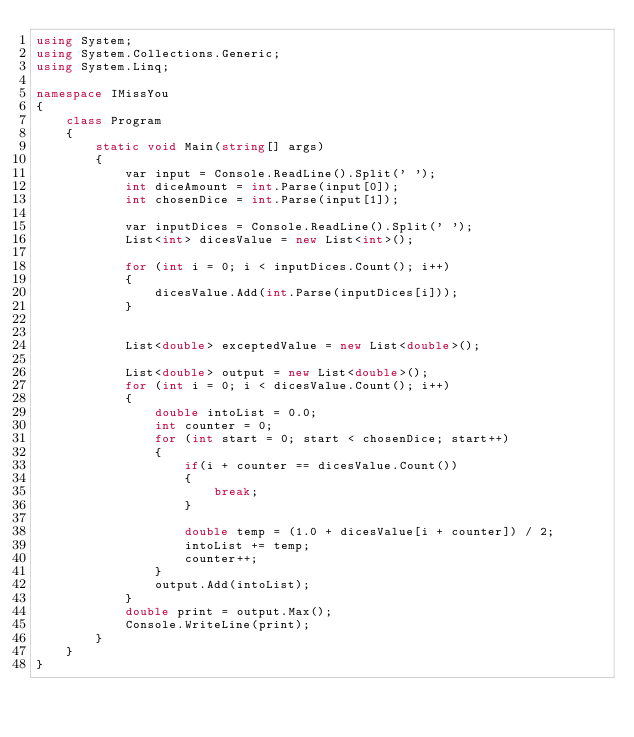Convert code to text. <code><loc_0><loc_0><loc_500><loc_500><_C#_>using System;
using System.Collections.Generic;
using System.Linq;

namespace IMissYou
{
    class Program
    {
        static void Main(string[] args)
        {
            var input = Console.ReadLine().Split(' ');
            int diceAmount = int.Parse(input[0]);
            int chosenDice = int.Parse(input[1]);

            var inputDices = Console.ReadLine().Split(' ');
            List<int> dicesValue = new List<int>();

            for (int i = 0; i < inputDices.Count(); i++)
            {
                dicesValue.Add(int.Parse(inputDices[i]));
            }


            List<double> exceptedValue = new List<double>();

            List<double> output = new List<double>();
            for (int i = 0; i < dicesValue.Count(); i++)
            {
                double intoList = 0.0;
                int counter = 0;
                for (int start = 0; start < chosenDice; start++)
                {
                    if(i + counter == dicesValue.Count())
                    {
                        break;
                    }

                    double temp = (1.0 + dicesValue[i + counter]) / 2;
                    intoList += temp;
                    counter++;
                }
                output.Add(intoList);
            }
            double print = output.Max();
            Console.WriteLine(print);
        }
    }
}</code> 